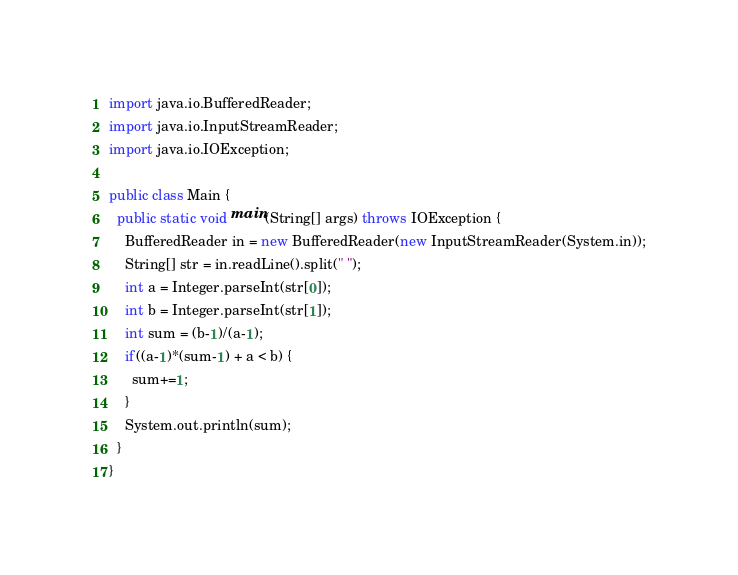Convert code to text. <code><loc_0><loc_0><loc_500><loc_500><_Java_>import java.io.BufferedReader;
import java.io.InputStreamReader;
import java.io.IOException;

public class Main {
  public static void main(String[] args) throws IOException {
    BufferedReader in = new BufferedReader(new InputStreamReader(System.in));
    String[] str = in.readLine().split(" ");
    int a = Integer.parseInt(str[0]);
    int b = Integer.parseInt(str[1]);
    int sum = (b-1)/(a-1);
    if((a-1)*(sum-1) + a < b) {
      sum+=1;
    }
    System.out.println(sum);
  }
}</code> 